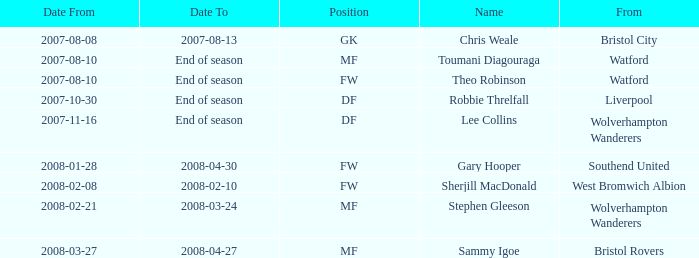What was the origin of the player holding the df position who started on 10/30/2007? Liverpool. 